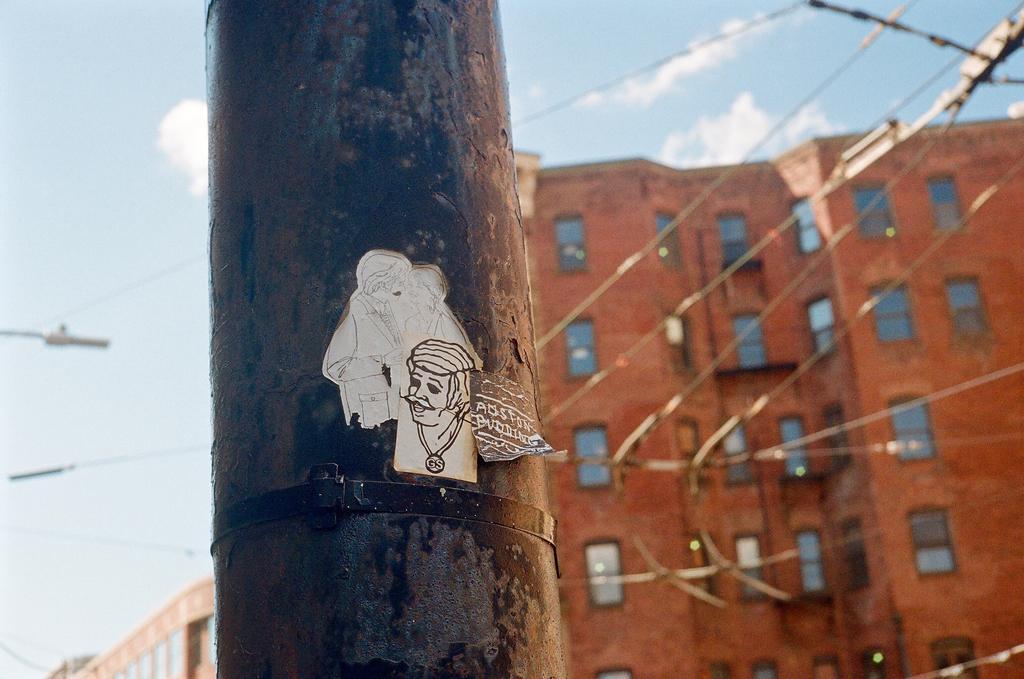In one or two sentences, can you explain what this image depicts? In this picture we can see a pole and in the background we can see buildings and sky with clouds. 